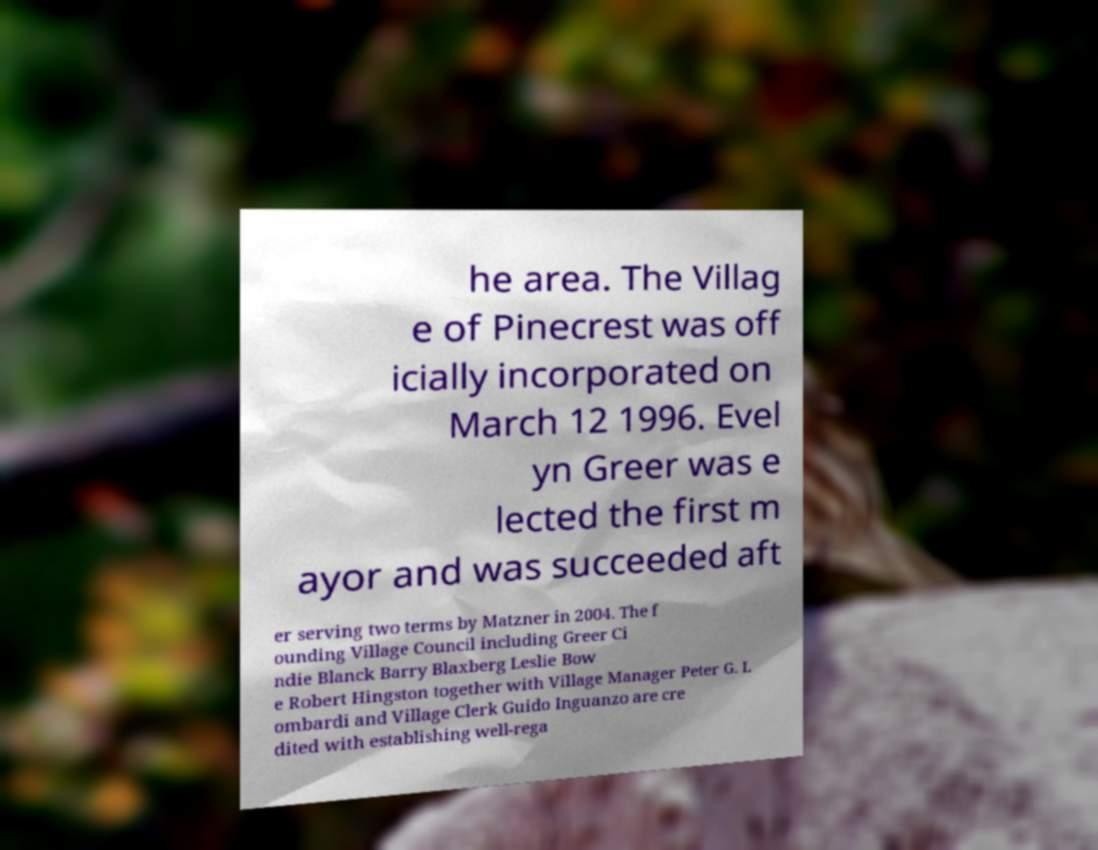Please identify and transcribe the text found in this image. he area. The Villag e of Pinecrest was off icially incorporated on March 12 1996. Evel yn Greer was e lected the first m ayor and was succeeded aft er serving two terms by Matzner in 2004. The f ounding Village Council including Greer Ci ndie Blanck Barry Blaxberg Leslie Bow e Robert Hingston together with Village Manager Peter G. L ombardi and Village Clerk Guido Inguanzo are cre dited with establishing well-rega 